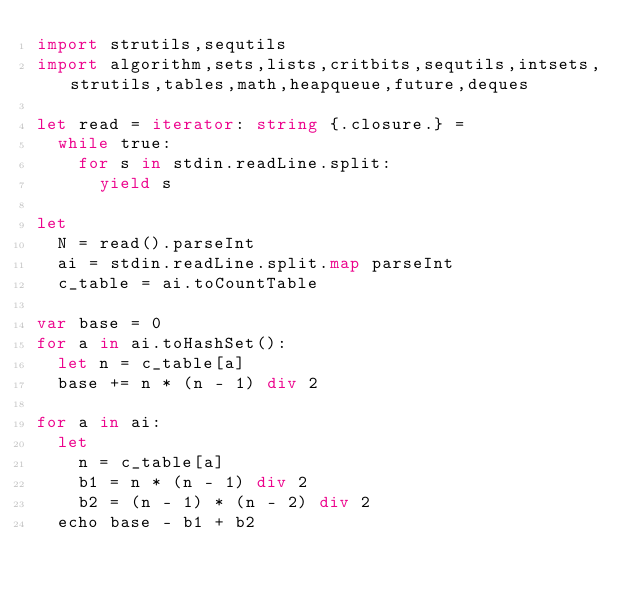Convert code to text. <code><loc_0><loc_0><loc_500><loc_500><_Nim_>import strutils,sequtils
import algorithm,sets,lists,critbits,sequtils,intsets,strutils,tables,math,heapqueue,future,deques

let read = iterator: string {.closure.} =
  while true:
    for s in stdin.readLine.split:
      yield s

let
  N = read().parseInt
  ai = stdin.readLine.split.map parseInt
  c_table = ai.toCountTable

var base = 0
for a in ai.toHashSet():
  let n = c_table[a]
  base += n * (n - 1) div 2

for a in ai:
  let
    n = c_table[a]
    b1 = n * (n - 1) div 2
    b2 = (n - 1) * (n - 2) div 2
  echo base - b1 + b2
</code> 